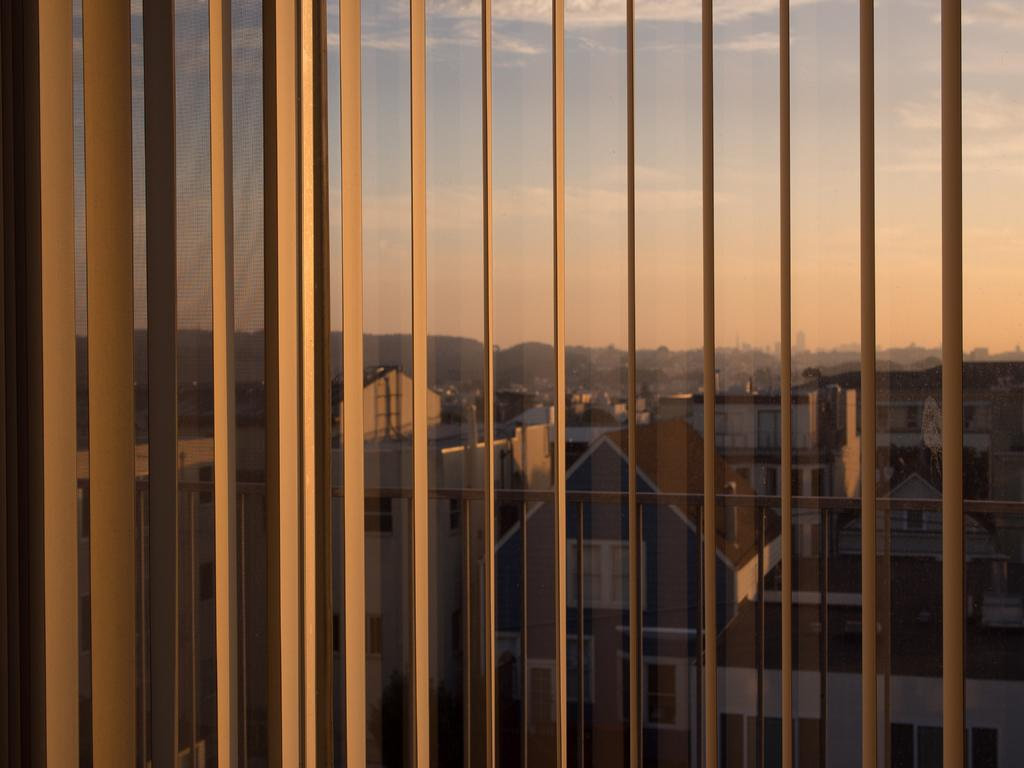What type of window covering is present in the image? There are window blinds in the image. What is located near the window blinds? There is a window in the image. What can be seen outside the window? Many buildings are visible outside the window. How would you describe the weather based on the image? The sky is cloudy in the image. How many girls are seen falling from the buildings in the image? There are no girls or falling depicted in the image; it only shows window blinds, a window, buildings, and a cloudy sky. 